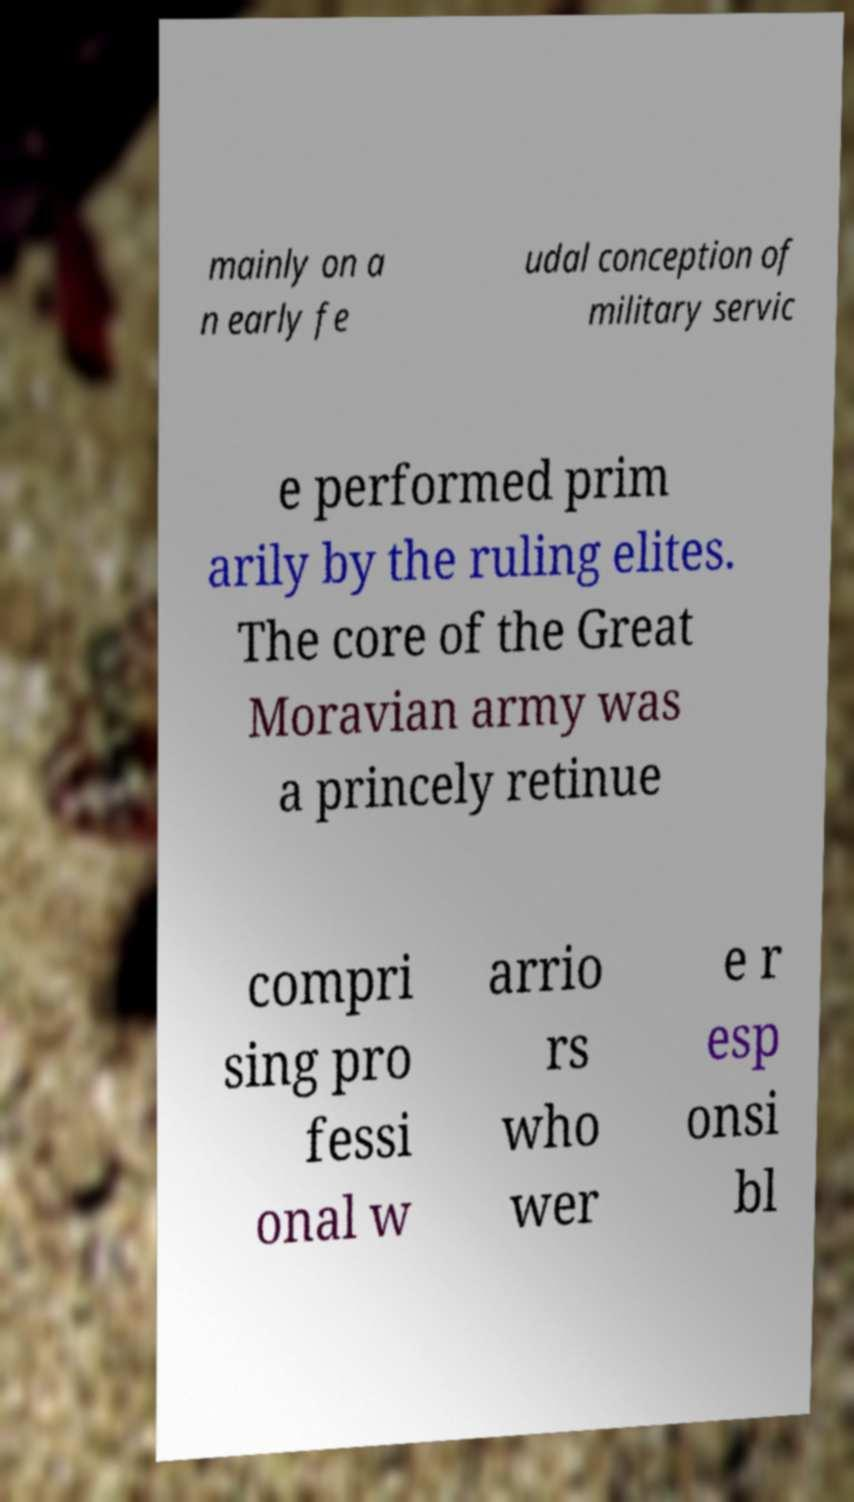I need the written content from this picture converted into text. Can you do that? mainly on a n early fe udal conception of military servic e performed prim arily by the ruling elites. The core of the Great Moravian army was a princely retinue compri sing pro fessi onal w arrio rs who wer e r esp onsi bl 